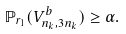<formula> <loc_0><loc_0><loc_500><loc_500>\mathbb { P } _ { r _ { 1 } } ( V _ { n _ { k } , 3 n _ { k } } ^ { b } ) \geq \alpha .</formula> 